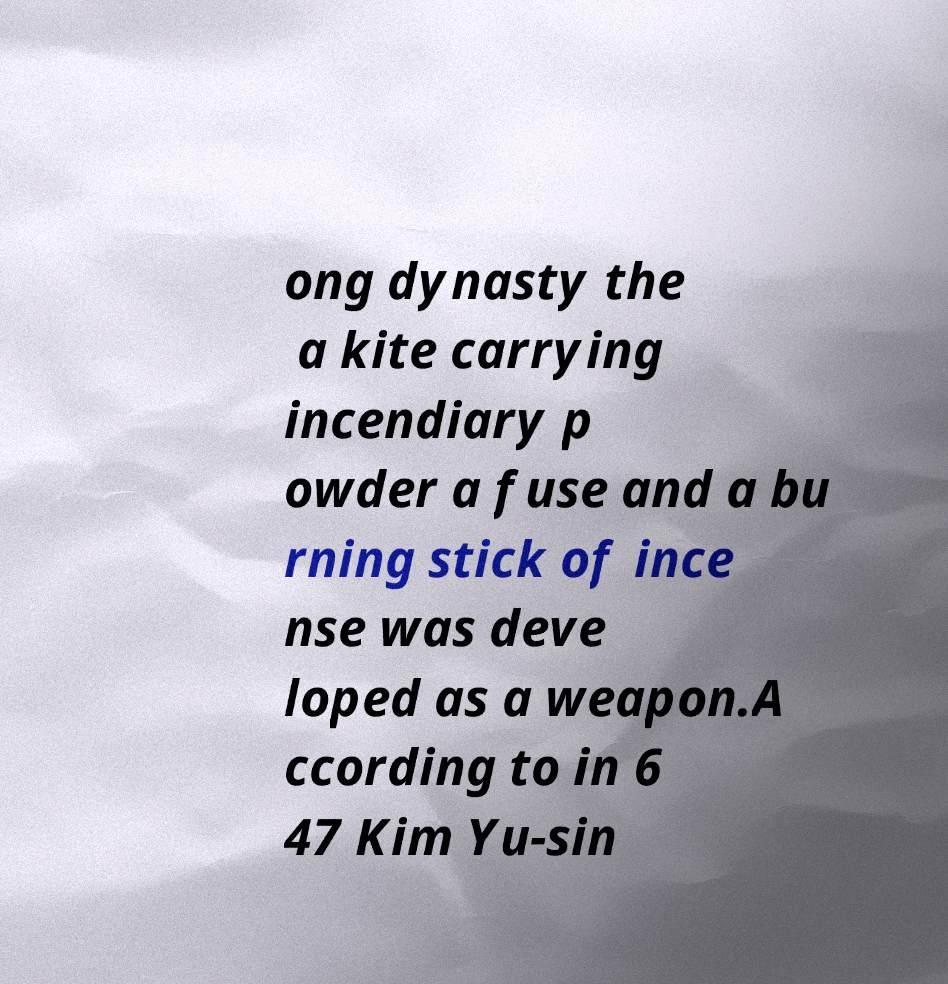Please read and relay the text visible in this image. What does it say? ong dynasty the a kite carrying incendiary p owder a fuse and a bu rning stick of ince nse was deve loped as a weapon.A ccording to in 6 47 Kim Yu-sin 